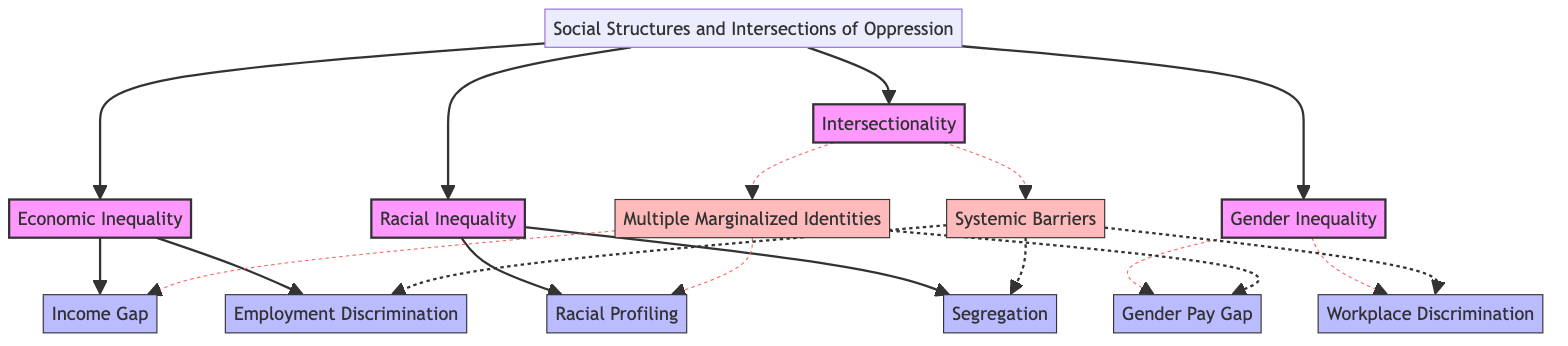What elements are included under Economic Inequality? The diagram shows two elements connected to Economic Inequality: Income Gap and Employment Discrimination. By looking at the block labeled Economic Inequality, we can see the elements branching out from it.
Answer: Income Gap, Employment Discrimination How many blocks represent different types of inequality? The diagram contains four blocks that represent different types of inequality: Economic Inequality, Racial Inequality, Gender Inequality, and Intersectionality. Counting the blocks gives us the answer.
Answer: 4 Which type of inequality includes the Gender Pay Gap? The Gender Pay Gap is listed under the block labeled Gender Inequality. By identifying the block's name and checking the elements listed below it, we can find the answer.
Answer: Gender Inequality What type of relationship exists between Multiple Marginalized Identities and Income Gap? The diagram indicates a dashed line (representing a specific relationship type) that connects Multiple Marginalized Identities to Income Gap. This specifically indicates that there is a sampling relationship between these two elements.
Answer: Relationship What is the common theme for the block labeled Intersectionality? The Intersectionality block showcases relationships that highlight how different types of injustice intersect in complex ways. It includes elements that connect to Economic, Racial, and Gender Inequalities, articulating the combined experience of those with multiple marginalized identities.
Answer: Intersecting oppression Which block has Systemic Barriers as one of its elements? Systemic Barriers is clearly identified within the Intersectionality block, as the elements of this block are directly linked to the systemic aspects of each inequality.
Answer: Intersectionality 